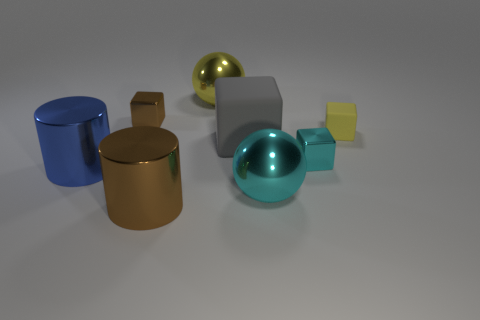Subtract all brown cubes. How many cubes are left? 3 Subtract all gray matte blocks. How many blocks are left? 3 Add 1 small cyan things. How many objects exist? 9 Subtract all green cubes. Subtract all purple cylinders. How many cubes are left? 4 Subtract all cylinders. How many objects are left? 6 Add 4 gray spheres. How many gray spheres exist? 4 Subtract 0 blue balls. How many objects are left? 8 Subtract all cyan objects. Subtract all large metallic cylinders. How many objects are left? 4 Add 1 metallic things. How many metallic things are left? 7 